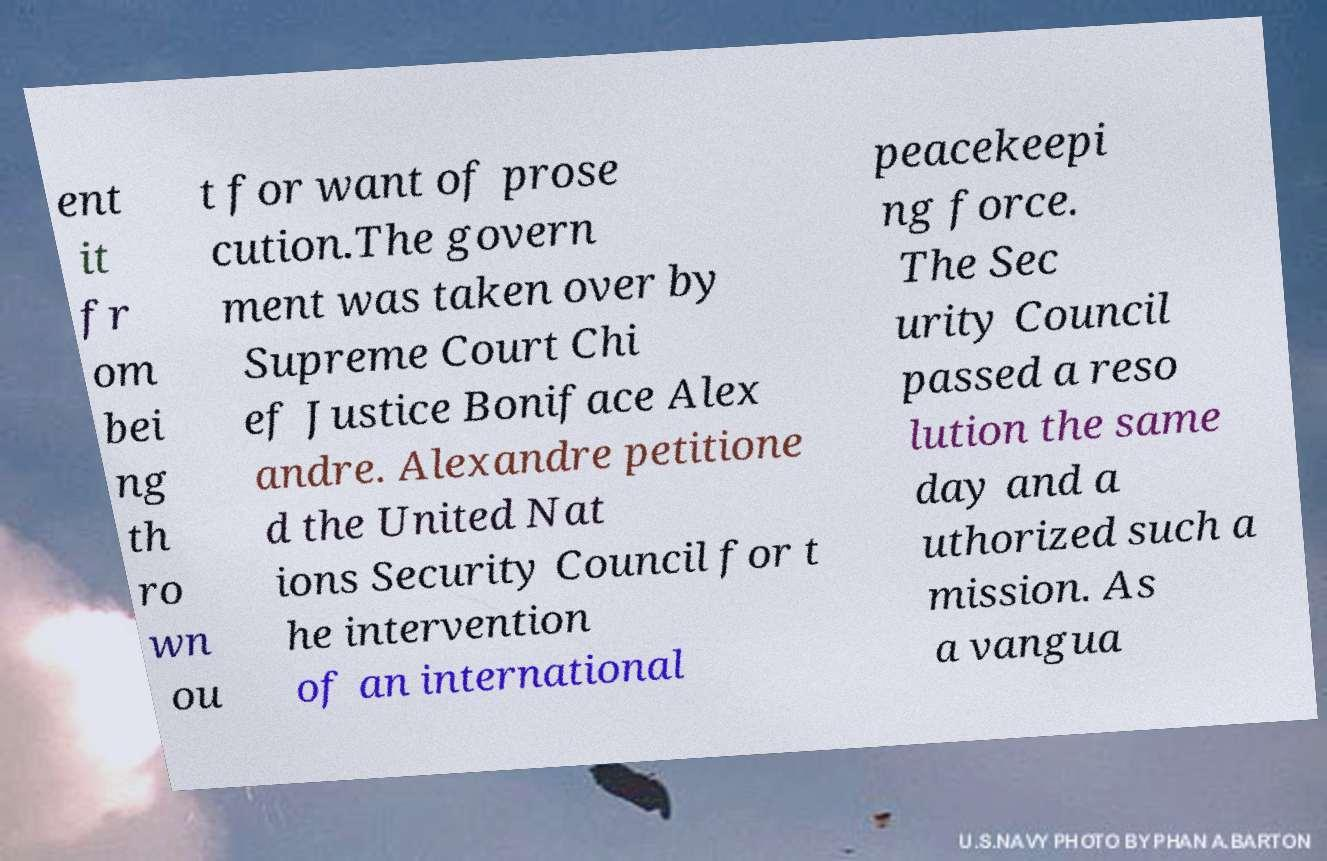Please read and relay the text visible in this image. What does it say? ent it fr om bei ng th ro wn ou t for want of prose cution.The govern ment was taken over by Supreme Court Chi ef Justice Boniface Alex andre. Alexandre petitione d the United Nat ions Security Council for t he intervention of an international peacekeepi ng force. The Sec urity Council passed a reso lution the same day and a uthorized such a mission. As a vangua 